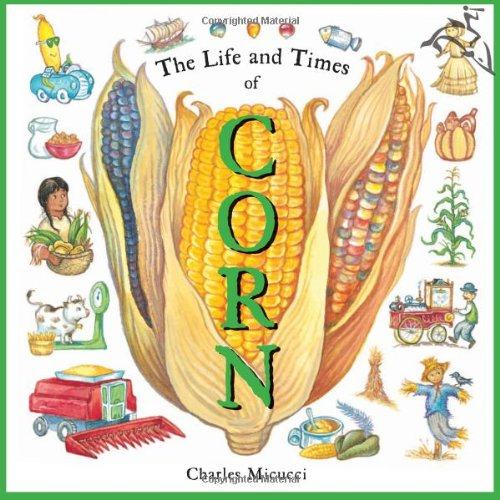Which types of uses for corn are illustrated on the cover of this book? The cover of 'The Life and Times of Corn' illustrates various uses of corn including food, farming, and even industrial uses. It shows corn on a cob, corn in native cooking, and corn being harvested by machinery. 